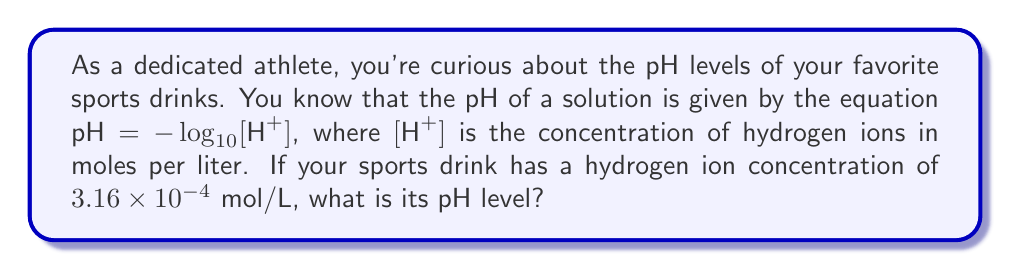Can you answer this question? Let's solve this step-by-step:

1) We're given the equation: $\text{pH} = -\log_{10}[\text{H}^+]$

2) We know that $[\text{H}^+] = 3.16 \times 10^{-4}$ mol/L

3) Let's substitute this into our equation:

   $\text{pH} = -\log_{10}(3.16 \times 10^{-4})$

4) We can simplify this using the laws of logarithms:

   $\text{pH} = -(\log_{10}3.16 + \log_{10}10^{-4})$

5) $\log_{10}10^{-4} = -4$, so:

   $\text{pH} = -(\log_{10}3.16 - 4)$

6) $\log_{10}3.16 \approx 0.5$, so:

   $\text{pH} = -(0.5 - 4) = -0.5 + 4 = 3.5$

Therefore, the pH of your sports drink is approximately 3.5.
Answer: 3.5 